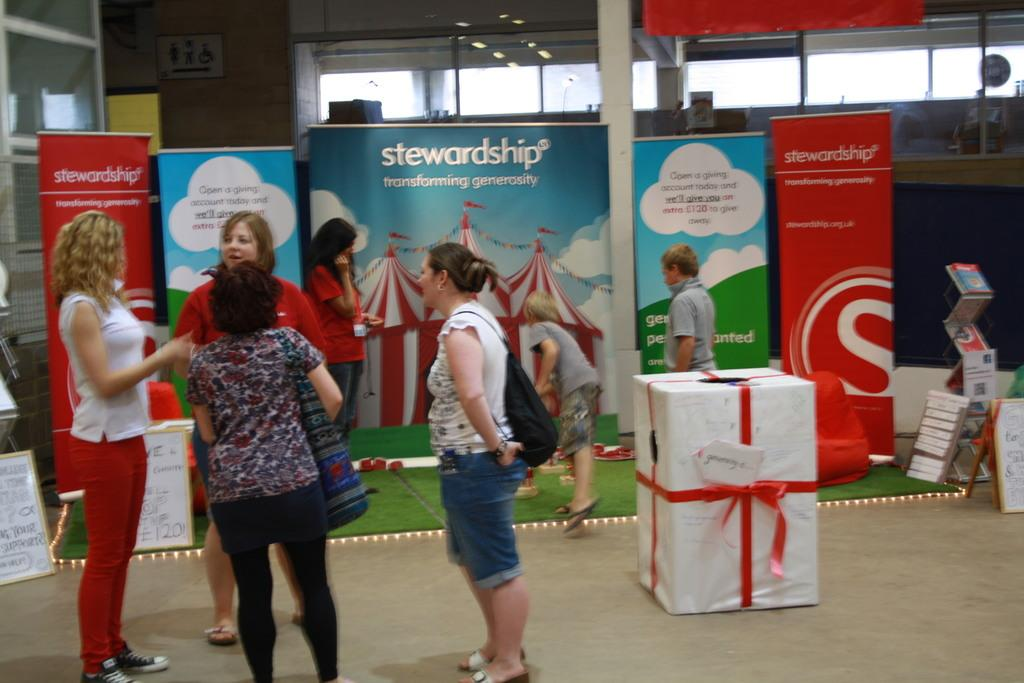<image>
Write a terse but informative summary of the picture. women standing in front of a sign that says 'stewardship' on it 